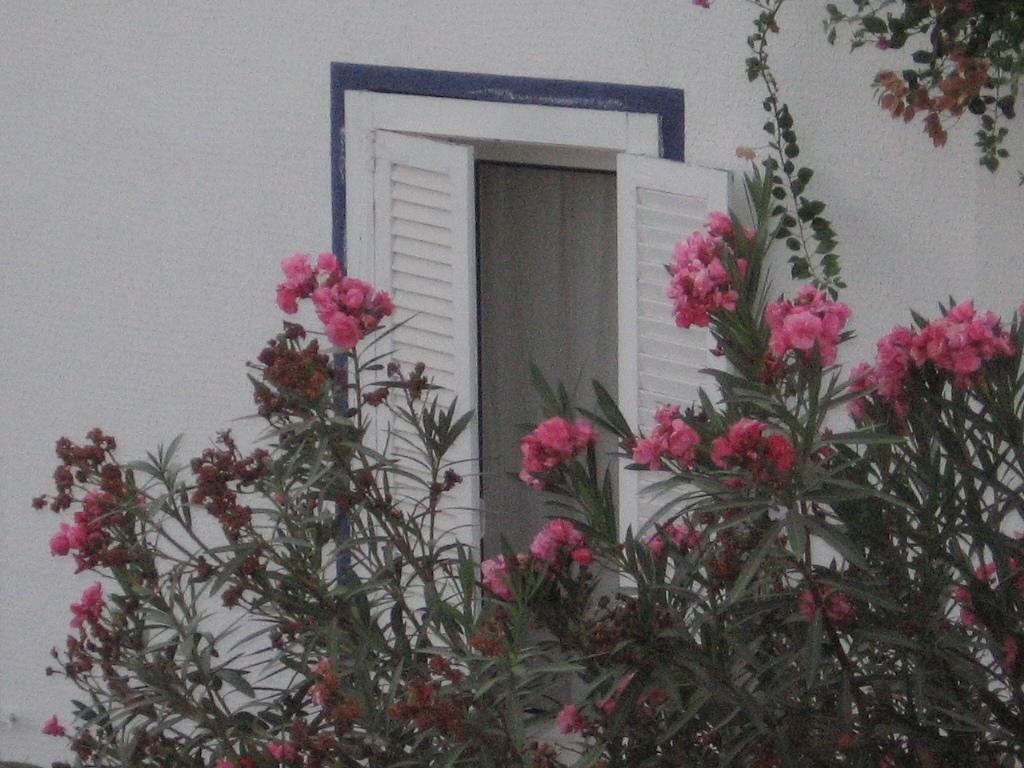What type of plants can be seen in the image? There are flowers and leaves in the image. What is visible in the background of the image? There is a window in the background of the image. Can you describe the tree in the image? There is a tree visible in the top right side of the image. What reason does the tree provide for the presence of spiders in the image? There are no spiders present in the image, and therefore no reason can be provided. 